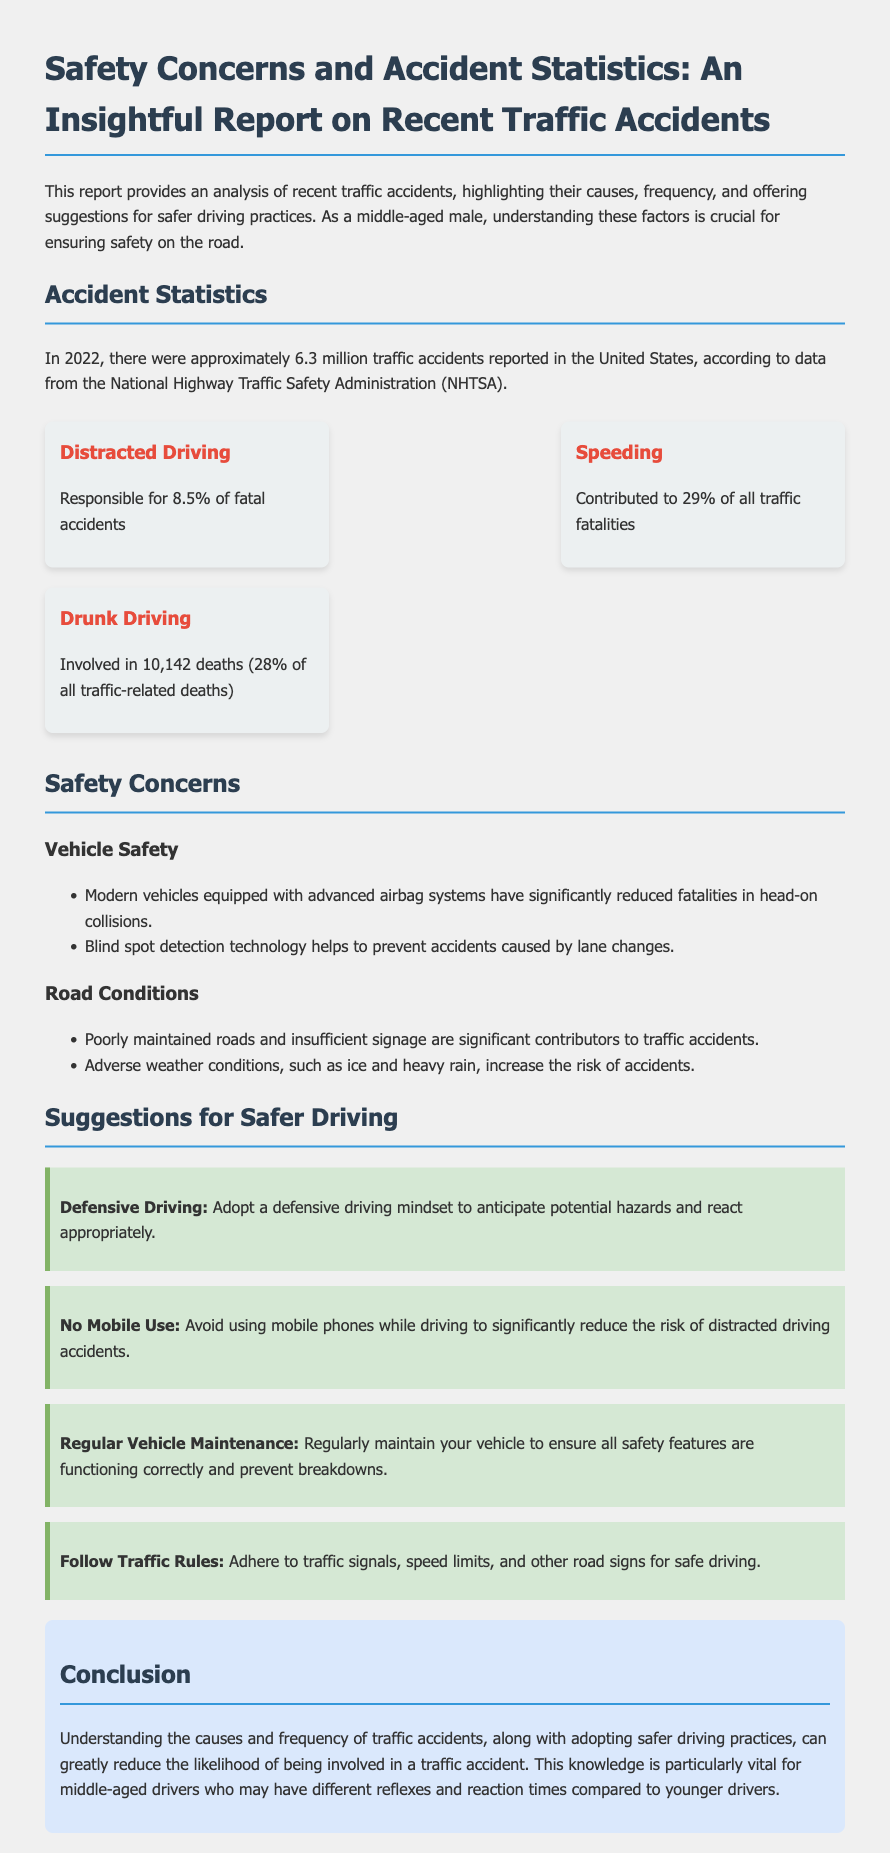What was the total number of traffic accidents in 2022? The document states that there were approximately 6.3 million traffic accidents reported in the United States in 2022.
Answer: 6.3 million What percentage of fatal accidents is caused by distracted driving? According to the document, distracted driving is responsible for 8.5% of fatal accidents.
Answer: 8.5% What is the leading cause of traffic fatalities according to the report? Speeding is indicated as contributing to 29% of all traffic fatalities in the report.
Answer: Speeding How many deaths were caused by drunk driving in 2022? The report mentions that drunk driving was involved in 10,142 deaths, accounting for 28% of all traffic-related deaths.
Answer: 10,142 What is one suggestion for safer driving practices mentioned in the report? The document provides several suggestions, one of which is to adopt a defensive driving mindset to anticipate potential hazards.
Answer: Defensive Driving What safety feature helps prevent accidents caused by lane changes? The report highlights blind spot detection technology as a feature that helps prevent such accidents.
Answer: Blind spot detection What two factors contribute significantly to traffic accidents according to road conditions section? The report specifies that poorly maintained roads and insufficient signage are significant contributors to accidents.
Answer: Poorly maintained roads, insufficient signage What is recommended to reduce the risk of distracted driving accidents? The document advises avoiding mobile phone use while driving to significantly reduce the risk.
Answer: No Mobile Use 